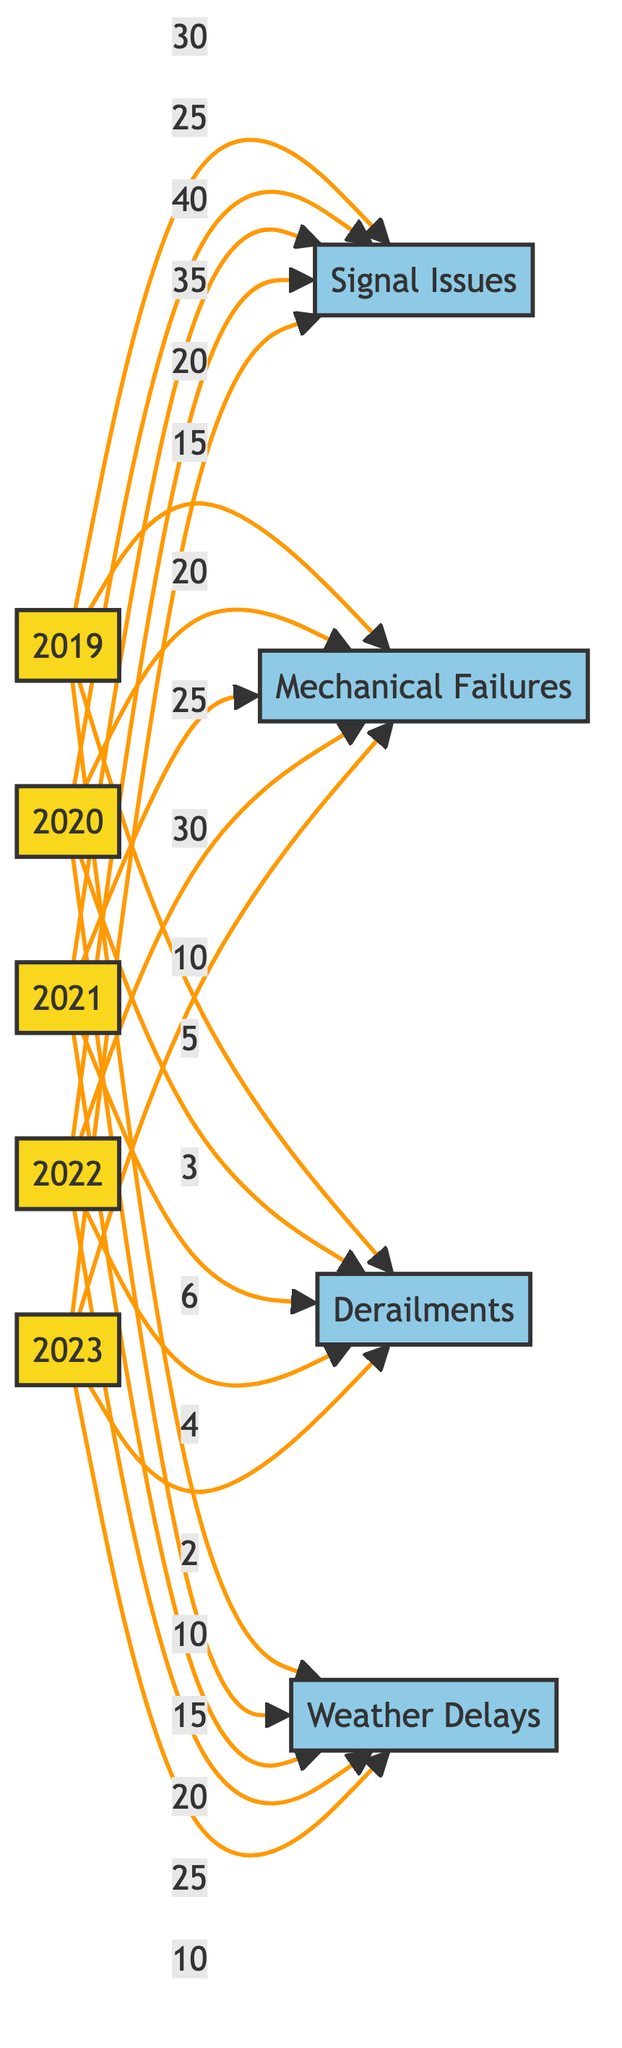What is the total number of signal issues reported in 2021? From the diagram, you can see that the node for 2021 is connected to the "Signal Issues" node with a value of 40. Therefore, the total number of signal issues reported in that year is 40.
Answer: 40 Which year had the highest frequency of mechanical failures? By examining the connection between each year and the "Mechanical Failures" node, you can identify that the year 2022 is linked with the highest value of 30, indicating the highest frequency of mechanical failures in that year.
Answer: 30 How many derailments were reported in 2019? The diagram shows that the 2019 node is connected to the "Derailments" node with a value of 5, which means that there were 5 derailments reported in 2019.
Answer: 5 Which type of delay had the lowest frequency in 2023? Looking at the values for 2023, the "Derailments" node has a value of 2, which is the lowest compared to the other delay types in that year (Signal Issues: 20, Mechanical Failures: 10, Weather Delays: 10). Therefore, the type of delay with the lowest frequency in 2023 is derailments.
Answer: Derailments In which year did weather delays peak, and what was the frequency? By observing the connections for the "Weather Delays" node, you see that it peaks in 2022 with a value of 25. Therefore, the peak year for weather delays is 2022, with a frequency of 25.
Answer: 2022, 25 Which issue had the highest total number of interruptions between 2019 and 2023? To find out the issue with the highest total interruptions, you can sum the values across all years for each type of issue. For signal issues: 30+25+40+35+20 = 150; for mechanical failures: 15+20+25+30+10 = 100; for derailments: 5+3+6+4+2 = 20; for weather delays: 10+15+20+25+10 = 80. The highest total is for signal issues with 150 interruptions.
Answer: Signal Issues How did the frequency of signal issues change from 2021 to 2023? You can find that signal issues were reported 40 times in 2021 and decreased to 20 times in 2023. Thus, the change reflects a decrease in frequency of 20 issues.
Answer: Decreased by 20 What is the sum of mechanical failures reported in 2022 and 2023? By referencing the values in the nodes, you can see that in 2022, mechanical failures had a reported value of 30, and in 2023, it was 10. Adding these together (30 + 10) gives you a total of 40 mechanical failures for those two years combined.
Answer: 40 Which service interruption had the most significant decrease from 2020 to 2023? By comparing the values for each interruption: Signal Issues decreased from 25 to 20 (5), Mechanical Failures from 20 to 10 (10), Derailments from 3 to 2 (1), and Weather Delays from 15 to 10 (5). The most significant decrease is for Mechanical Failures, with a decrease of 10 interruptions.
Answer: Mechanical Failures 